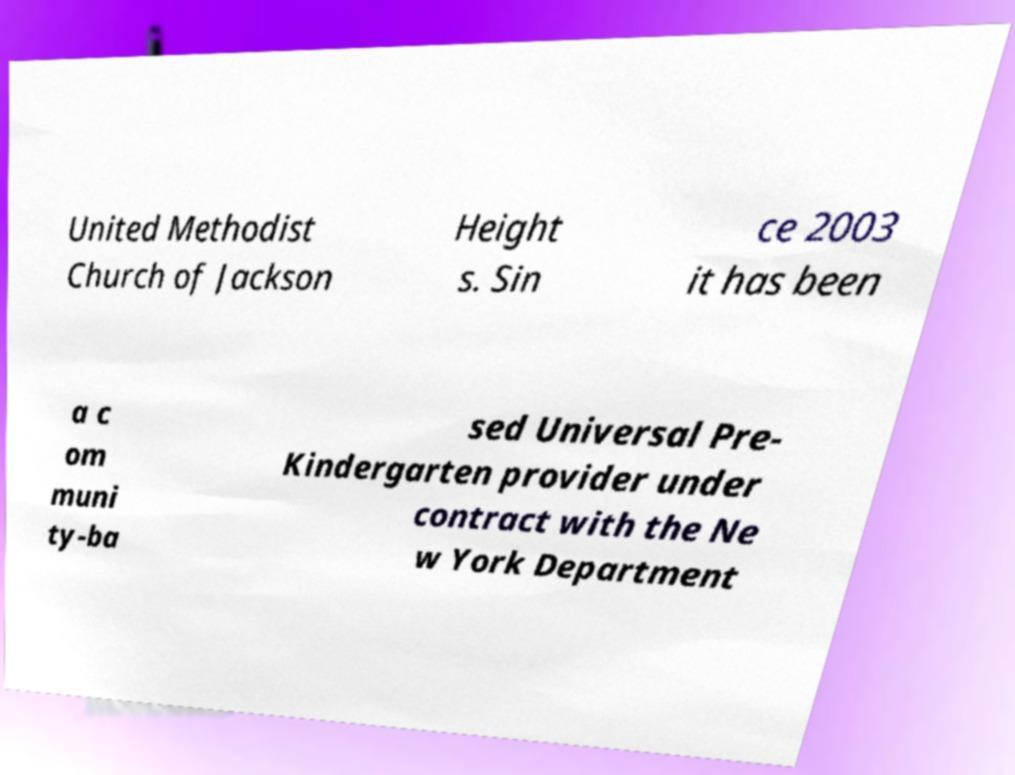Can you read and provide the text displayed in the image?This photo seems to have some interesting text. Can you extract and type it out for me? United Methodist Church of Jackson Height s. Sin ce 2003 it has been a c om muni ty-ba sed Universal Pre- Kindergarten provider under contract with the Ne w York Department 